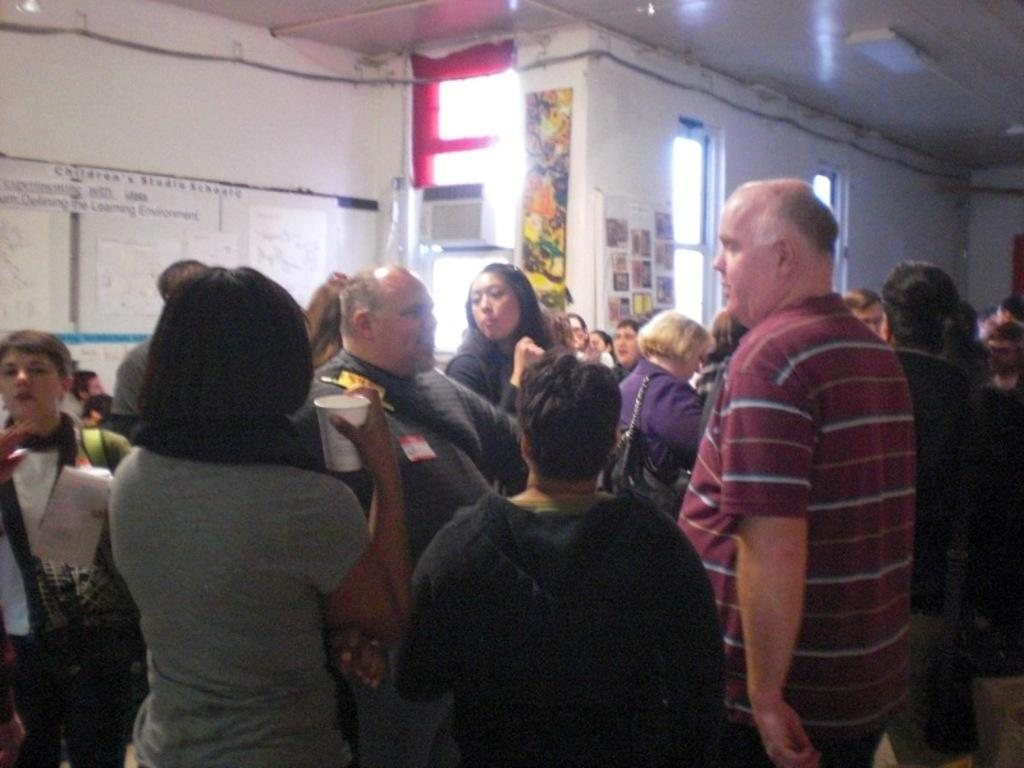How many people are in the image? There are people in the image, but the exact number is not specified. What are some people doing in the image? Some people are holding objects, and some are wearing bags. What can be seen on the wall in the background? There are boards on the wall in the background. What is visible in the background that provides light? There are lights visible in the background. What type of crown is being worn by the person in the image? There is no crown visible in the image; people are wearing bags instead. What is the alarm sounding like in the image? There is no alarm present in the image. 